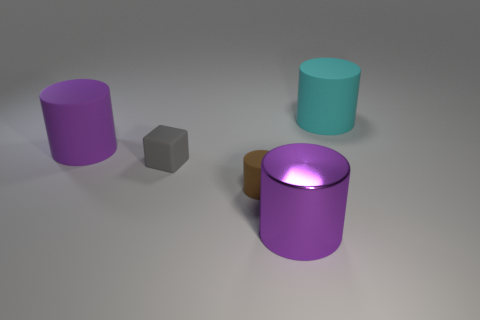Subtract all cylinders. How many objects are left? 1 Subtract 3 cylinders. How many cylinders are left? 1 Subtract all purple cylinders. Subtract all purple blocks. How many cylinders are left? 2 Subtract all blue balls. How many brown cylinders are left? 1 Subtract all big cyan cylinders. Subtract all brown rubber objects. How many objects are left? 3 Add 1 big cyan objects. How many big cyan objects are left? 2 Add 1 big purple cylinders. How many big purple cylinders exist? 3 Add 2 large purple metallic cylinders. How many objects exist? 7 Subtract all cyan cylinders. How many cylinders are left? 3 Subtract all small cylinders. How many cylinders are left? 3 